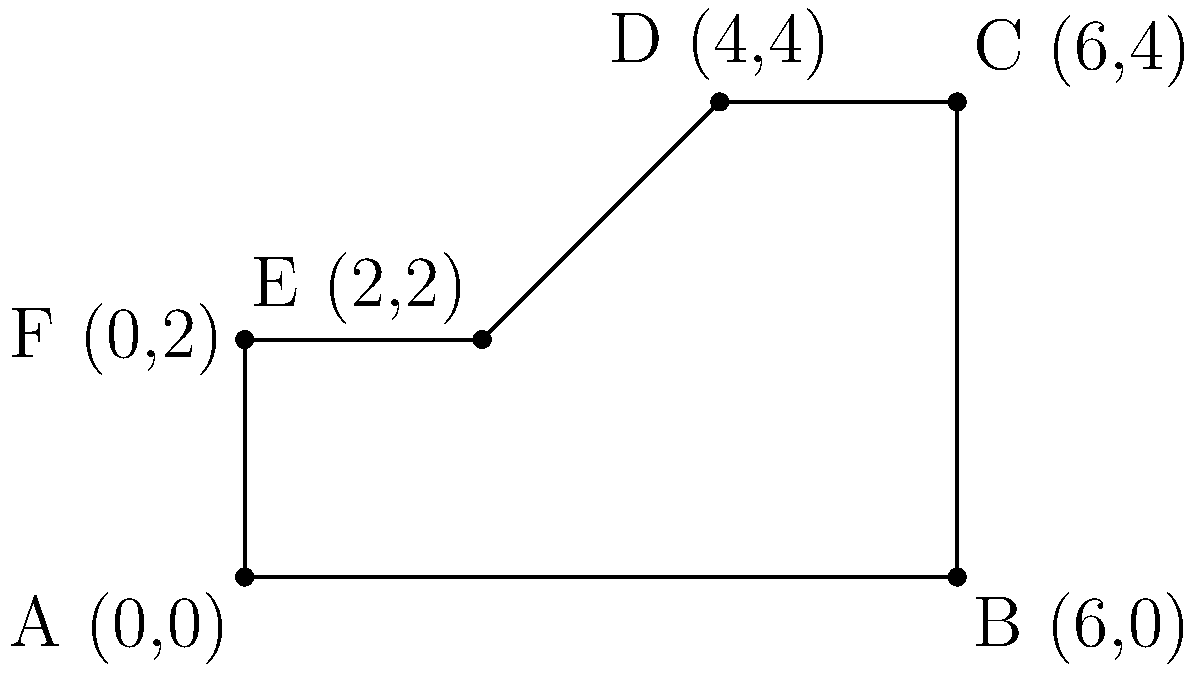A ski binding base plate has a polygonal shape as shown in the figure. The coordinates of the vertices are A(0,0), B(6,0), C(6,4), D(4,4), E(2,2), and F(0,2). Calculate the area of this base plate using coordinate geometry methods. To find the area of this irregular polygon, we can use the Shoelace formula (also known as the surveyor's formula). The steps are as follows:

1) The Shoelace formula for a polygon with vertices $(x_1, y_1), (x_2, y_2), ..., (x_n, y_n)$ is:

   Area = $\frac{1}{2}|((x_1y_2 + x_2y_3 + ... + x_ny_1) - (y_1x_2 + y_2x_3 + ... + y_nx_1))|$

2) For our polygon:
   $(x_1, y_1) = (0, 0)$
   $(x_2, y_2) = (6, 0)$
   $(x_3, y_3) = (6, 4)$
   $(x_4, y_4) = (4, 4)$
   $(x_5, y_5) = (2, 2)$
   $(x_6, y_6) = (0, 2)$

3) Applying the formula:

   Area = $\frac{1}{2}|(0 \cdot 0 + 6 \cdot 4 + 6 \cdot 4 + 4 \cdot 2 + 2 \cdot 2 + 0 \cdot 0) - (0 \cdot 6 + 0 \cdot 6 + 4 \cdot 4 + 4 \cdot 2 + 2 \cdot 0 + 2 \cdot 0)|$

4) Simplifying:

   Area = $\frac{1}{2}|(0 + 24 + 24 + 8 + 4 + 0) - (0 + 0 + 16 + 8 + 0 + 0)|$
   
   Area = $\frac{1}{2}|60 - 24|$
   
   Area = $\frac{1}{2} \cdot 36 = 18$

Therefore, the area of the ski binding base plate is 18 square units.
Answer: 18 square units 